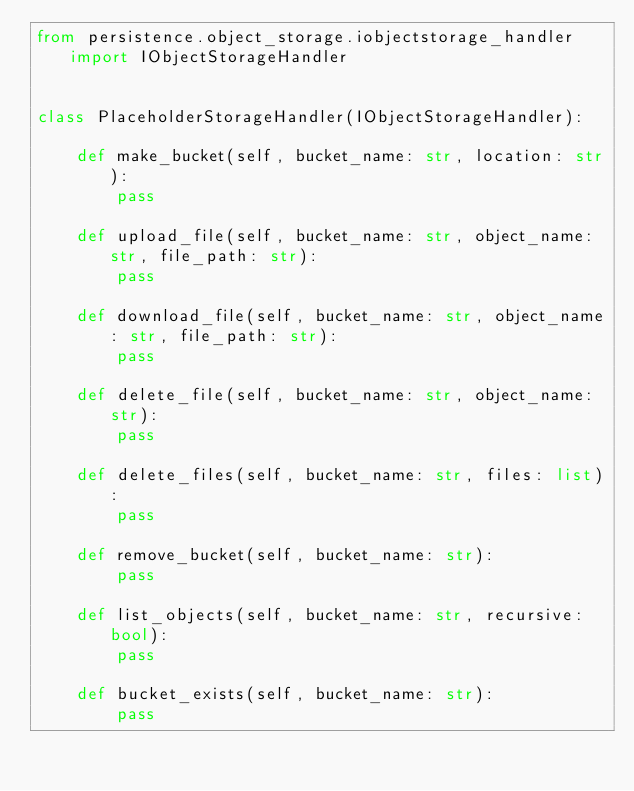Convert code to text. <code><loc_0><loc_0><loc_500><loc_500><_Python_>from persistence.object_storage.iobjectstorage_handler import IObjectStorageHandler


class PlaceholderStorageHandler(IObjectStorageHandler):

    def make_bucket(self, bucket_name: str, location: str):
        pass

    def upload_file(self, bucket_name: str, object_name: str, file_path: str):
        pass

    def download_file(self, bucket_name: str, object_name: str, file_path: str):
        pass

    def delete_file(self, bucket_name: str, object_name: str):
        pass

    def delete_files(self, bucket_name: str, files: list):
        pass

    def remove_bucket(self, bucket_name: str):
        pass

    def list_objects(self, bucket_name: str, recursive: bool):
        pass

    def bucket_exists(self, bucket_name: str):
        pass</code> 